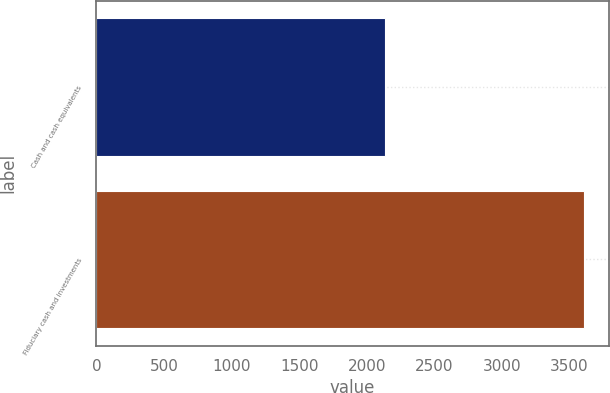<chart> <loc_0><loc_0><loc_500><loc_500><bar_chart><fcel>Cash and cash equivalents<fcel>Fiduciary cash and investments<nl><fcel>2133<fcel>3612<nl></chart> 